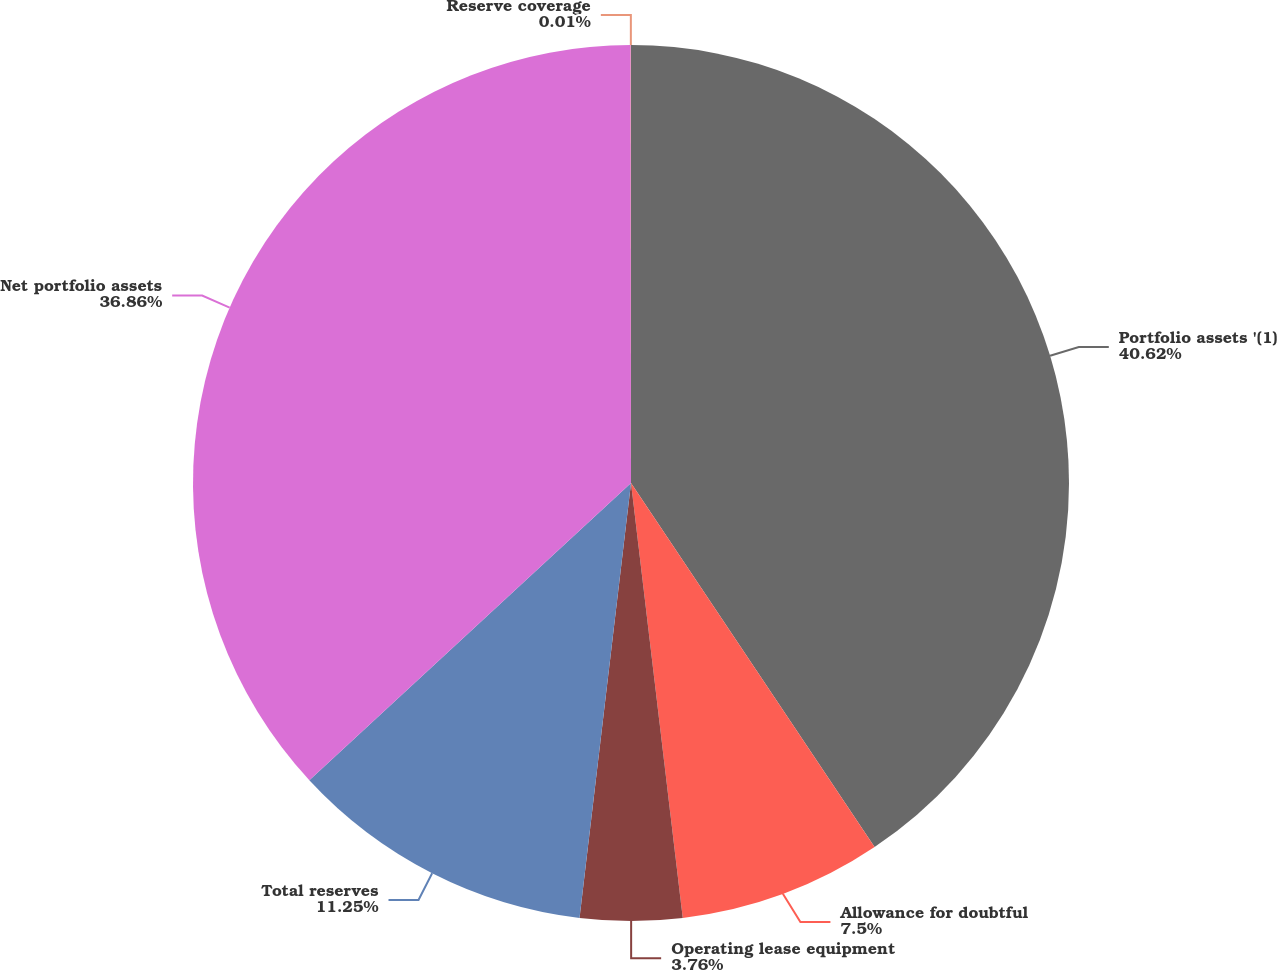Convert chart. <chart><loc_0><loc_0><loc_500><loc_500><pie_chart><fcel>Portfolio assets '(1)<fcel>Allowance for doubtful<fcel>Operating lease equipment<fcel>Total reserves<fcel>Net portfolio assets<fcel>Reserve coverage<nl><fcel>40.61%<fcel>7.5%<fcel>3.76%<fcel>11.25%<fcel>36.86%<fcel>0.01%<nl></chart> 